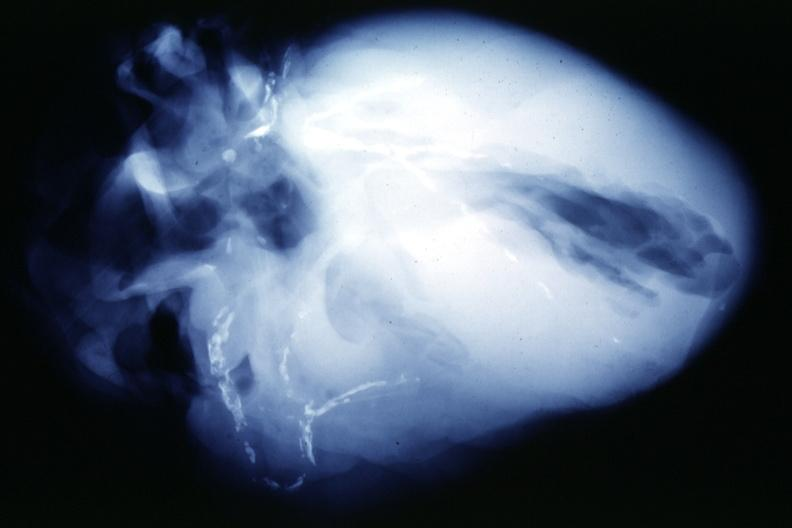does mesentery show x-ray postmortextensive lesions in this x-ray of whole heart?
Answer the question using a single word or phrase. No 